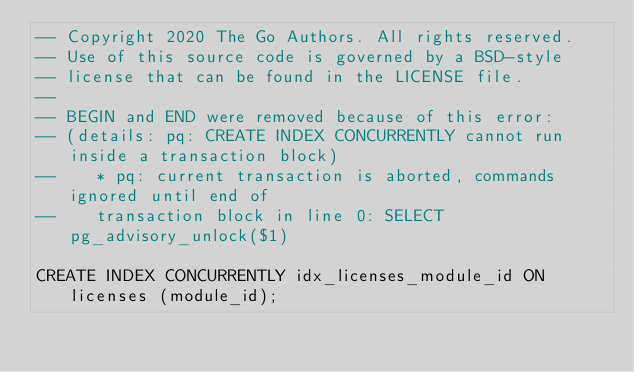Convert code to text. <code><loc_0><loc_0><loc_500><loc_500><_SQL_>-- Copyright 2020 The Go Authors. All rights reserved.
-- Use of this source code is governed by a BSD-style
-- license that can be found in the LICENSE file.
--
-- BEGIN and END were removed because of this error:
-- (details: pq: CREATE INDEX CONCURRENTLY cannot run inside a transaction block)
--	  * pq: current transaction is aborted, commands ignored until end of
--    transaction block in line 0: SELECT pg_advisory_unlock($1)

CREATE INDEX CONCURRENTLY idx_licenses_module_id ON licenses (module_id);
</code> 